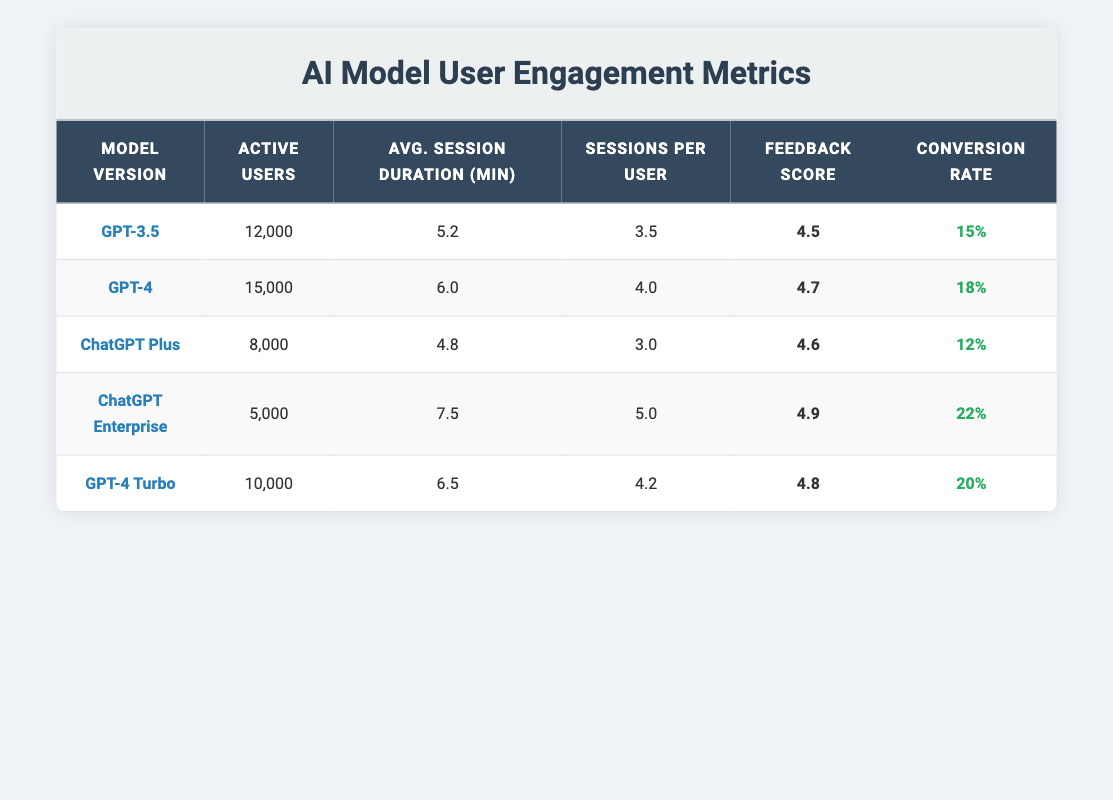What is the active user count for GPT-4? The active user count for GPT-4 is explicitly stated in the table under the "Active Users" column.
Answer: 15,000 Which model version has the highest feedback score? By checking the "Feedback Score" column, ChatGPT Enterprise has the highest score of 4.9 compared to other models.
Answer: ChatGPT Enterprise How many total active users are there across all model versions? To find the total active users, I add the active users from all models: 12000 + 15000 + 8000 + 5000 + 10000 = 50000.
Answer: 50,000 Does GPT-3.5 have a higher average session duration than ChatGPT Plus? By comparing the "Avg. Session Duration" values, GPT-3.5 has an average of 5.2 minutes, while ChatGPT Plus has 4.8 minutes, which means GPT-3.5 does have a higher duration.
Answer: Yes What is the conversion rate for the model version with the most active users? Looking at the active user counts, GPT-4 has the most active users at 15,000 with a conversion rate of 0.18.
Answer: 0.18 What is the difference in sessions per user between ChatGPT Enterprise and GPT-4 Turbo? The sessions per user for ChatGPT Enterprise is 5.0 and for GPT-4 Turbo is 4.2. The difference is 5.0 - 4.2 = 0.8.
Answer: 0.8 Is the average session duration of GPT-4 Turbo greater than the average session duration of GPT-3.5? The average session duration for GPT-4 Turbo is 6.5 minutes and for GPT-3.5 it is 5.2 minutes, so GPT-4 Turbo has a longer duration.
Answer: Yes Which model version has both the highest conversion rate and the highest feedback score? ChatGPT Enterprise has the highest conversion rate of 0.22 and also the highest feedback score of 4.9, making it the top model in both metrics.
Answer: ChatGPT Enterprise How many sessions per user does GPT-4 have compared to ChatGPT Plus? GPT-4 has 4.0 sessions per user whereas ChatGPT Plus has 3.0 sessions per user, indicating GPT-4 has 1 additional session.
Answer: 1 session more 